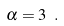<formula> <loc_0><loc_0><loc_500><loc_500>\alpha = 3 \ .</formula> 